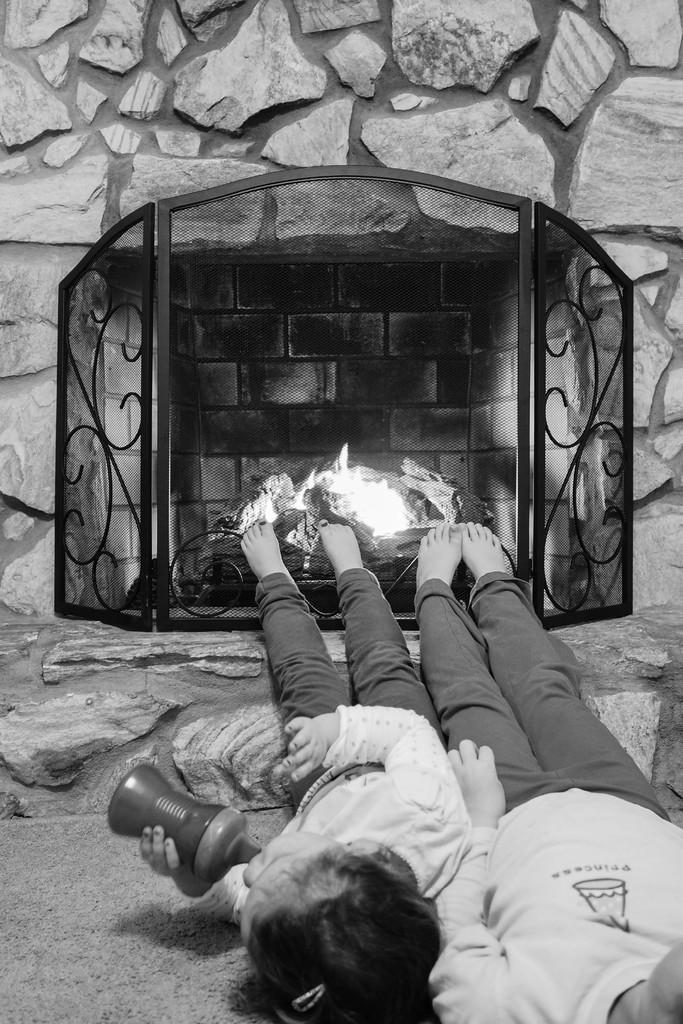How would you summarize this image in a sentence or two? In this image there are two persons lying on the floor, and in the background there is a fire place, wall. 